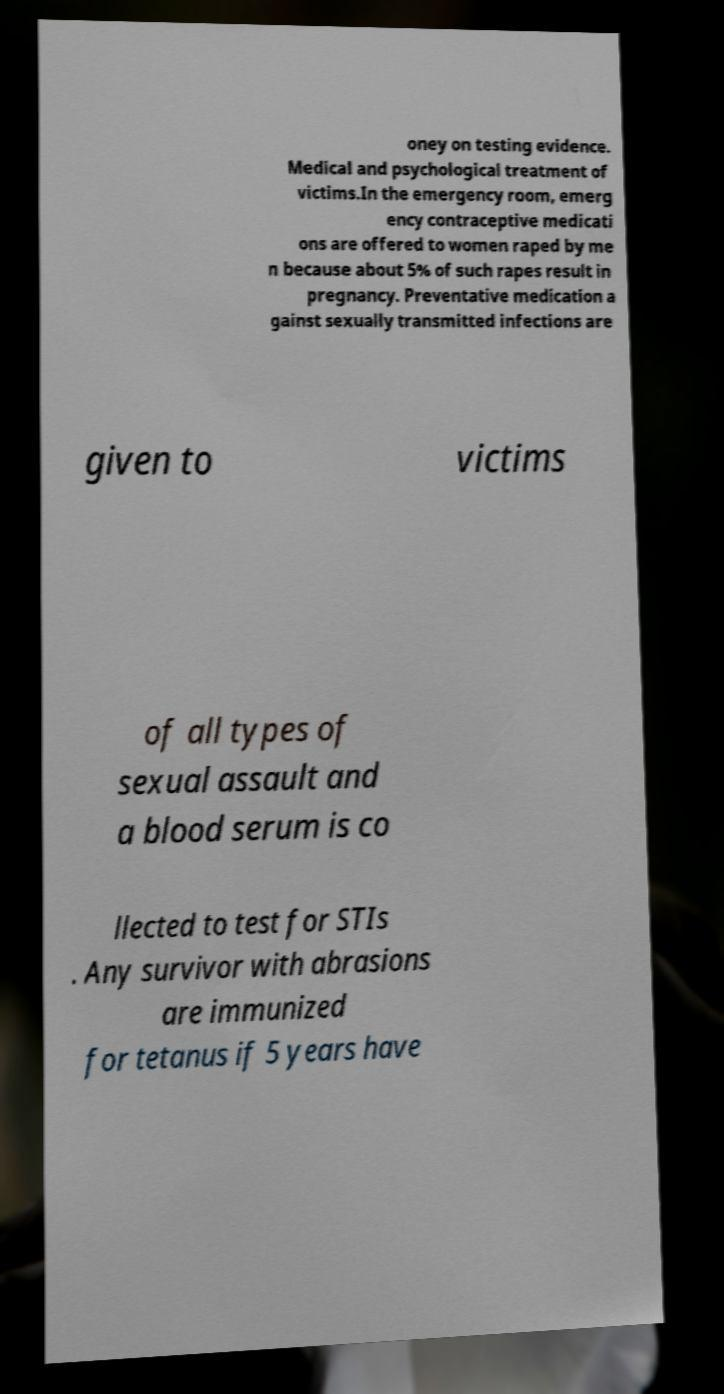There's text embedded in this image that I need extracted. Can you transcribe it verbatim? oney on testing evidence. Medical and psychological treatment of victims.In the emergency room, emerg ency contraceptive medicati ons are offered to women raped by me n because about 5% of such rapes result in pregnancy. Preventative medication a gainst sexually transmitted infections are given to victims of all types of sexual assault and a blood serum is co llected to test for STIs . Any survivor with abrasions are immunized for tetanus if 5 years have 